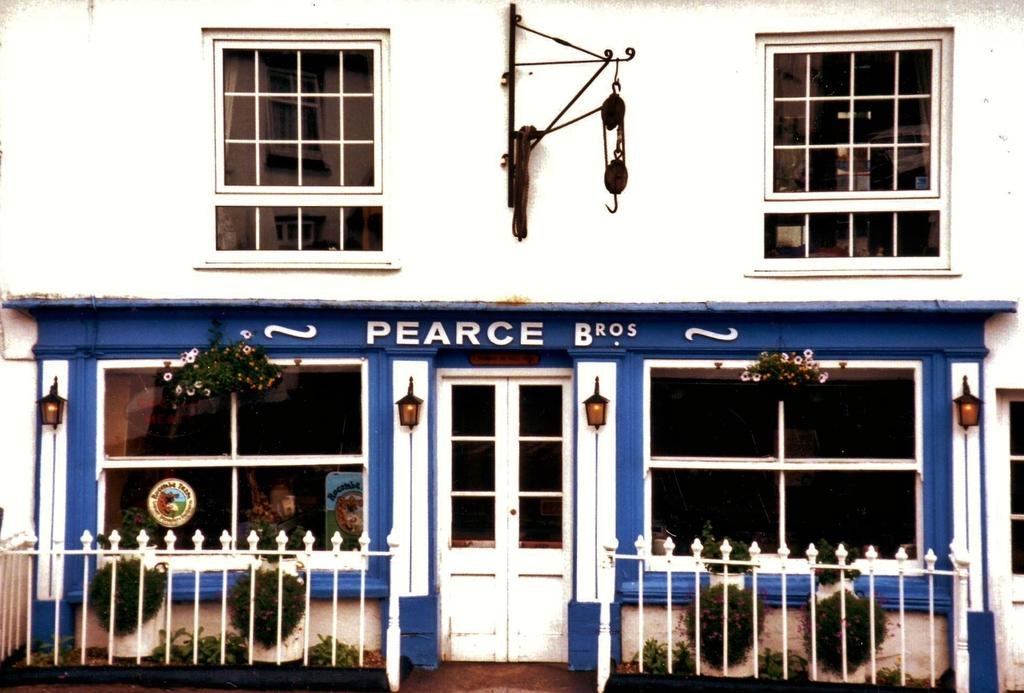What type of structure is visible in the image? There is a building in the image. What can be seen on the building? There is text on the building. What architectural features are present in the building? There are windows, doors, lights, and railings in the building. What else can be seen in the image besides the building? There are plants in the image. Can you hear the ice laughing in the image? There is no ice or laughter present in the image; it only features a building with various architectural features and plants. 